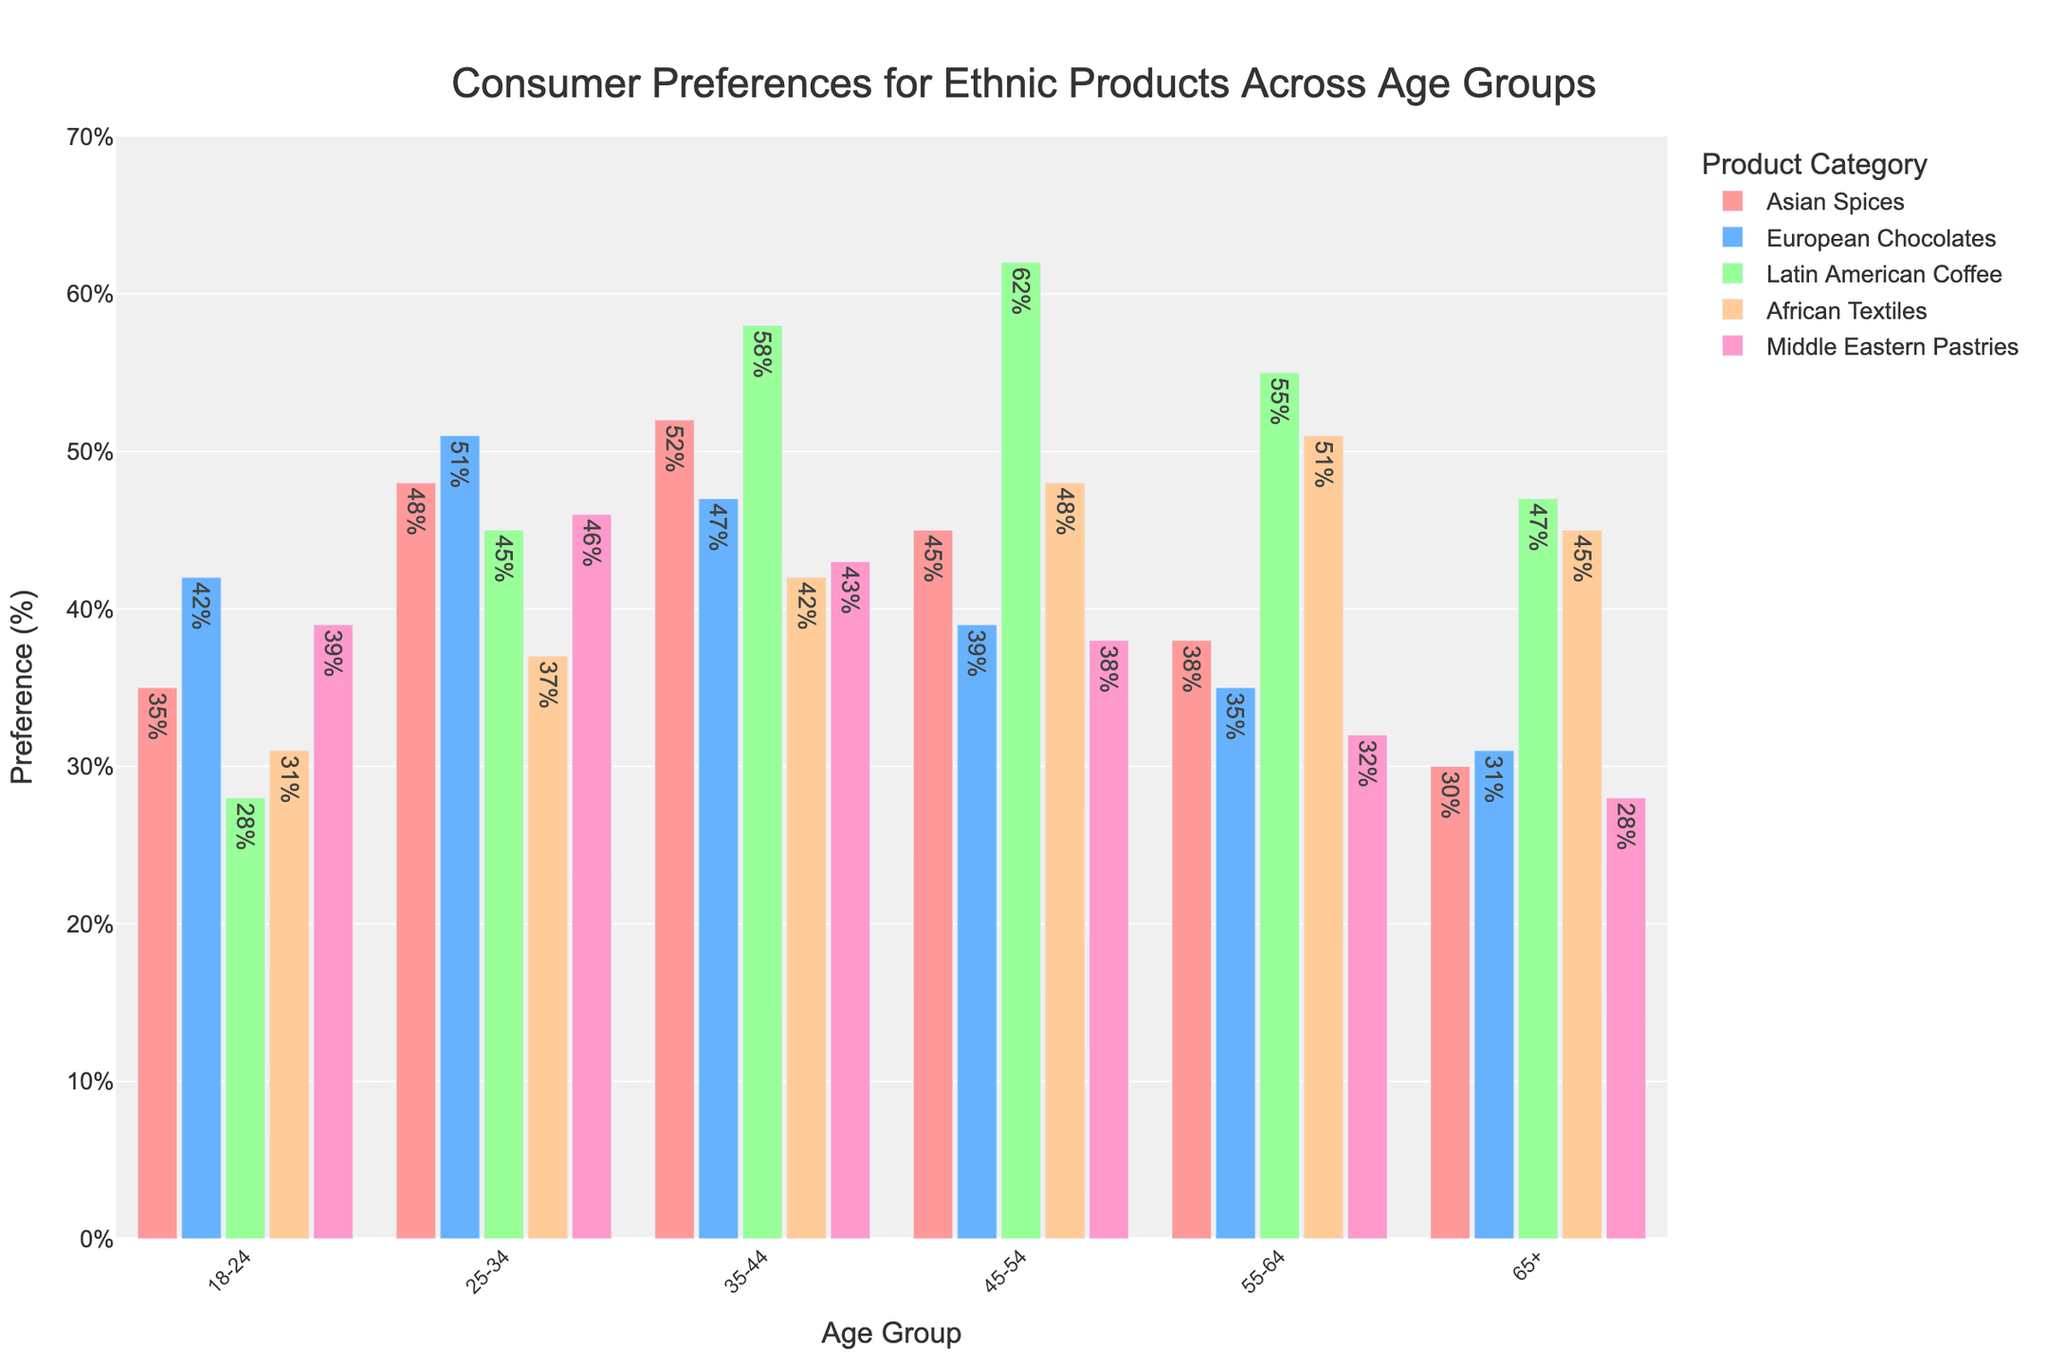Which age group has the highest preference for Latin American Coffee? To find the age group with the highest preference for Latin American Coffee, look for the tallest bar in the Latin American Coffee category. The tallest bar corresponds to the 45-54 age group with 62%.
Answer: 45-54 Which product category do the 18-24 age group prefer the most? Locate the bars for the 18-24 age group and identify the tallest one. The tallest bar in this group is for European Chocolates at 42%.
Answer: European Chocolates How much higher is the preference for African Textiles in the 55-64 age group compared to the 18-24 age group? The preference for African Textiles in the 55-64 age group is 51%, and for the 18-24 age group, it is 31%. The difference is 51% - 31%.
Answer: 20% What is the average preference for Middle Eastern Pastries across all age groups? Sum the preferences for Middle Eastern Pastries across all age groups and divide by the number of age groups: (39% + 46% + 43% + 38% + 32% + 28%) / 6 = 226% / 6.
Answer: 37.67% Do the 25-34 age group prefer Asian Spices or African Textiles more, and by how much? The preference for Asian Spices in the 25-34 age group is 48%, and for African Textiles, it is 37%. The difference is 48% - 37%.
Answer: Asian Spices by 11% Which product shows the most consistent preference (smallest range) across all age groups? Calculate the range (max preference - min preference) for each product across all age groups. The smallest range can be found by comparing these ranges: Asian Spices (52% - 30% = 22%), European Chocolates (51% - 31% = 20%), Latin American Coffee (62% - 28% = 34%), African Textiles (51% - 31% = 20%), Middle Eastern Pastries (46% - 28% = 18%).
Answer: Middle Eastern Pastries Which age group has the lowest preference for European Chocolates and what percentage is it? Find the shortest bar in the European Chocolates category and note the corresponding age group and percentage. The shortest bar corresponds to the 65+ age group with 31%.
Answer: 65+, 31% When combining preferences, do the 35-44 age group prefer Asian Spices and Latin American Coffee more than the 55-64 age group? Sum the preferences for Asian Spices and Latin American Coffee in the 35-44 age group (52% + 58% = 110%) and the 55-64 age group (38% + 55% = 93%). Check if 110% > 93%.
Answer: Yes, by 17% 